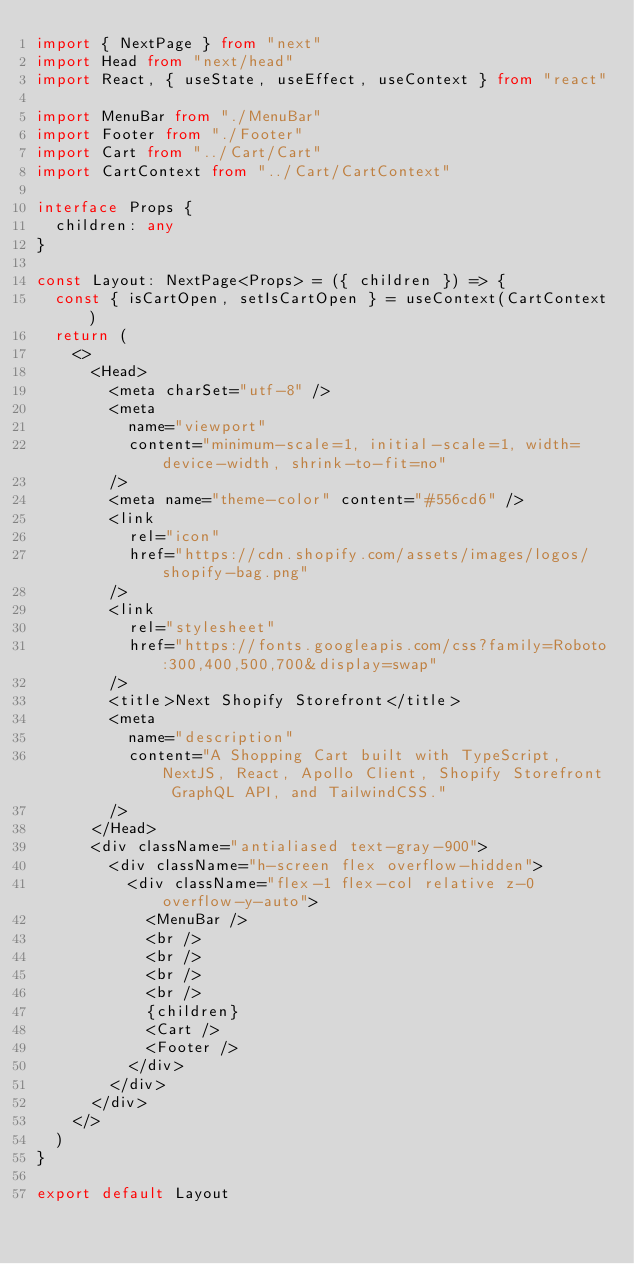<code> <loc_0><loc_0><loc_500><loc_500><_TypeScript_>import { NextPage } from "next"
import Head from "next/head"
import React, { useState, useEffect, useContext } from "react"

import MenuBar from "./MenuBar"
import Footer from "./Footer"
import Cart from "../Cart/Cart"
import CartContext from "../Cart/CartContext"

interface Props {
  children: any
}

const Layout: NextPage<Props> = ({ children }) => {
  const { isCartOpen, setIsCartOpen } = useContext(CartContext)
  return (
    <>
      <Head>
        <meta charSet="utf-8" />
        <meta
          name="viewport"
          content="minimum-scale=1, initial-scale=1, width=device-width, shrink-to-fit=no"
        />
        <meta name="theme-color" content="#556cd6" />
        <link
          rel="icon"
          href="https://cdn.shopify.com/assets/images/logos/shopify-bag.png"
        />
        <link
          rel="stylesheet"
          href="https://fonts.googleapis.com/css?family=Roboto:300,400,500,700&display=swap"
        />
        <title>Next Shopify Storefront</title>
        <meta
          name="description"
          content="A Shopping Cart built with TypeScript, NextJS, React, Apollo Client, Shopify Storefront GraphQL API, and TailwindCSS."
        />
      </Head>
      <div className="antialiased text-gray-900">
        <div className="h-screen flex overflow-hidden">
          <div className="flex-1 flex-col relative z-0 overflow-y-auto">
            <MenuBar />
            <br />
            <br />
            <br />
            <br />
            {children}
            <Cart />
            <Footer />
          </div>
        </div>
      </div>
    </>
  )
}

export default Layout
</code> 